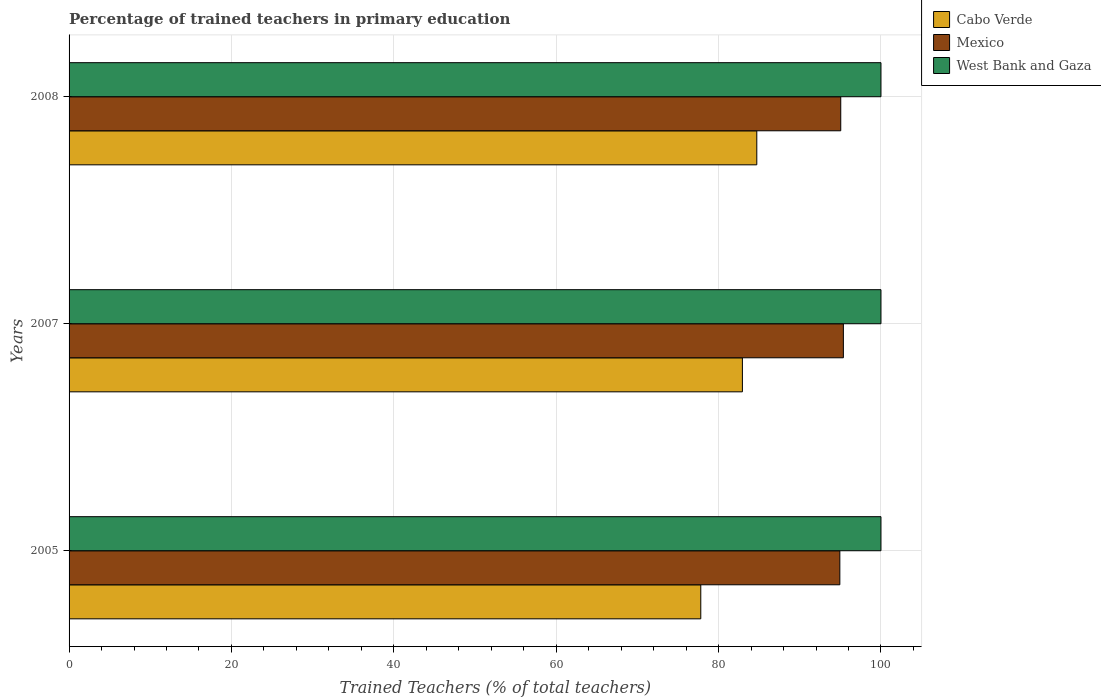How many different coloured bars are there?
Your answer should be compact. 3. How many bars are there on the 3rd tick from the top?
Your answer should be very brief. 3. In how many cases, is the number of bars for a given year not equal to the number of legend labels?
Your answer should be compact. 0. What is the percentage of trained teachers in Mexico in 2007?
Offer a terse response. 95.37. In which year was the percentage of trained teachers in Mexico minimum?
Offer a very short reply. 2005. What is the total percentage of trained teachers in West Bank and Gaza in the graph?
Keep it short and to the point. 300. What is the difference between the percentage of trained teachers in Cabo Verde in 2005 and that in 2008?
Provide a short and direct response. -6.9. What is the difference between the percentage of trained teachers in Cabo Verde in 2005 and the percentage of trained teachers in West Bank and Gaza in 2008?
Keep it short and to the point. -22.19. What is the average percentage of trained teachers in Mexico per year?
Make the answer very short. 95.12. In the year 2007, what is the difference between the percentage of trained teachers in Mexico and percentage of trained teachers in West Bank and Gaza?
Offer a very short reply. -4.63. In how many years, is the percentage of trained teachers in Mexico greater than 56 %?
Make the answer very short. 3. What is the ratio of the percentage of trained teachers in Mexico in 2005 to that in 2008?
Make the answer very short. 1. Is the percentage of trained teachers in Cabo Verde in 2007 less than that in 2008?
Your answer should be very brief. Yes. What is the difference between the highest and the second highest percentage of trained teachers in Cabo Verde?
Keep it short and to the point. 1.77. Is it the case that in every year, the sum of the percentage of trained teachers in Mexico and percentage of trained teachers in West Bank and Gaza is greater than the percentage of trained teachers in Cabo Verde?
Your response must be concise. Yes. How many bars are there?
Offer a terse response. 9. What is the difference between two consecutive major ticks on the X-axis?
Your answer should be compact. 20. Are the values on the major ticks of X-axis written in scientific E-notation?
Provide a short and direct response. No. What is the title of the graph?
Make the answer very short. Percentage of trained teachers in primary education. Does "Honduras" appear as one of the legend labels in the graph?
Your answer should be very brief. No. What is the label or title of the X-axis?
Ensure brevity in your answer.  Trained Teachers (% of total teachers). What is the label or title of the Y-axis?
Make the answer very short. Years. What is the Trained Teachers (% of total teachers) of Cabo Verde in 2005?
Give a very brief answer. 77.81. What is the Trained Teachers (% of total teachers) in Mexico in 2005?
Provide a succinct answer. 94.93. What is the Trained Teachers (% of total teachers) in Cabo Verde in 2007?
Offer a very short reply. 82.93. What is the Trained Teachers (% of total teachers) of Mexico in 2007?
Keep it short and to the point. 95.37. What is the Trained Teachers (% of total teachers) of West Bank and Gaza in 2007?
Your response must be concise. 100. What is the Trained Teachers (% of total teachers) in Cabo Verde in 2008?
Keep it short and to the point. 84.71. What is the Trained Teachers (% of total teachers) of Mexico in 2008?
Give a very brief answer. 95.05. What is the Trained Teachers (% of total teachers) of West Bank and Gaza in 2008?
Make the answer very short. 100. Across all years, what is the maximum Trained Teachers (% of total teachers) of Cabo Verde?
Offer a terse response. 84.71. Across all years, what is the maximum Trained Teachers (% of total teachers) of Mexico?
Ensure brevity in your answer.  95.37. Across all years, what is the maximum Trained Teachers (% of total teachers) in West Bank and Gaza?
Ensure brevity in your answer.  100. Across all years, what is the minimum Trained Teachers (% of total teachers) in Cabo Verde?
Provide a short and direct response. 77.81. Across all years, what is the minimum Trained Teachers (% of total teachers) of Mexico?
Offer a very short reply. 94.93. What is the total Trained Teachers (% of total teachers) of Cabo Verde in the graph?
Give a very brief answer. 245.45. What is the total Trained Teachers (% of total teachers) in Mexico in the graph?
Provide a short and direct response. 285.35. What is the total Trained Teachers (% of total teachers) in West Bank and Gaza in the graph?
Your response must be concise. 300. What is the difference between the Trained Teachers (% of total teachers) of Cabo Verde in 2005 and that in 2007?
Provide a short and direct response. -5.13. What is the difference between the Trained Teachers (% of total teachers) of Mexico in 2005 and that in 2007?
Your answer should be compact. -0.43. What is the difference between the Trained Teachers (% of total teachers) of West Bank and Gaza in 2005 and that in 2007?
Your answer should be compact. 0. What is the difference between the Trained Teachers (% of total teachers) of Cabo Verde in 2005 and that in 2008?
Your answer should be compact. -6.9. What is the difference between the Trained Teachers (% of total teachers) of Mexico in 2005 and that in 2008?
Your response must be concise. -0.11. What is the difference between the Trained Teachers (% of total teachers) in Cabo Verde in 2007 and that in 2008?
Offer a very short reply. -1.77. What is the difference between the Trained Teachers (% of total teachers) in Mexico in 2007 and that in 2008?
Make the answer very short. 0.32. What is the difference between the Trained Teachers (% of total teachers) in Cabo Verde in 2005 and the Trained Teachers (% of total teachers) in Mexico in 2007?
Give a very brief answer. -17.56. What is the difference between the Trained Teachers (% of total teachers) in Cabo Verde in 2005 and the Trained Teachers (% of total teachers) in West Bank and Gaza in 2007?
Make the answer very short. -22.19. What is the difference between the Trained Teachers (% of total teachers) of Mexico in 2005 and the Trained Teachers (% of total teachers) of West Bank and Gaza in 2007?
Provide a succinct answer. -5.07. What is the difference between the Trained Teachers (% of total teachers) in Cabo Verde in 2005 and the Trained Teachers (% of total teachers) in Mexico in 2008?
Provide a succinct answer. -17.24. What is the difference between the Trained Teachers (% of total teachers) of Cabo Verde in 2005 and the Trained Teachers (% of total teachers) of West Bank and Gaza in 2008?
Provide a short and direct response. -22.19. What is the difference between the Trained Teachers (% of total teachers) of Mexico in 2005 and the Trained Teachers (% of total teachers) of West Bank and Gaza in 2008?
Keep it short and to the point. -5.07. What is the difference between the Trained Teachers (% of total teachers) in Cabo Verde in 2007 and the Trained Teachers (% of total teachers) in Mexico in 2008?
Your response must be concise. -12.11. What is the difference between the Trained Teachers (% of total teachers) in Cabo Verde in 2007 and the Trained Teachers (% of total teachers) in West Bank and Gaza in 2008?
Provide a succinct answer. -17.07. What is the difference between the Trained Teachers (% of total teachers) in Mexico in 2007 and the Trained Teachers (% of total teachers) in West Bank and Gaza in 2008?
Your answer should be compact. -4.63. What is the average Trained Teachers (% of total teachers) of Cabo Verde per year?
Ensure brevity in your answer.  81.82. What is the average Trained Teachers (% of total teachers) of Mexico per year?
Keep it short and to the point. 95.12. What is the average Trained Teachers (% of total teachers) in West Bank and Gaza per year?
Keep it short and to the point. 100. In the year 2005, what is the difference between the Trained Teachers (% of total teachers) of Cabo Verde and Trained Teachers (% of total teachers) of Mexico?
Your response must be concise. -17.13. In the year 2005, what is the difference between the Trained Teachers (% of total teachers) in Cabo Verde and Trained Teachers (% of total teachers) in West Bank and Gaza?
Your response must be concise. -22.19. In the year 2005, what is the difference between the Trained Teachers (% of total teachers) of Mexico and Trained Teachers (% of total teachers) of West Bank and Gaza?
Your answer should be compact. -5.07. In the year 2007, what is the difference between the Trained Teachers (% of total teachers) in Cabo Verde and Trained Teachers (% of total teachers) in Mexico?
Your answer should be very brief. -12.43. In the year 2007, what is the difference between the Trained Teachers (% of total teachers) in Cabo Verde and Trained Teachers (% of total teachers) in West Bank and Gaza?
Make the answer very short. -17.07. In the year 2007, what is the difference between the Trained Teachers (% of total teachers) in Mexico and Trained Teachers (% of total teachers) in West Bank and Gaza?
Provide a short and direct response. -4.63. In the year 2008, what is the difference between the Trained Teachers (% of total teachers) of Cabo Verde and Trained Teachers (% of total teachers) of Mexico?
Your answer should be compact. -10.34. In the year 2008, what is the difference between the Trained Teachers (% of total teachers) of Cabo Verde and Trained Teachers (% of total teachers) of West Bank and Gaza?
Provide a short and direct response. -15.29. In the year 2008, what is the difference between the Trained Teachers (% of total teachers) in Mexico and Trained Teachers (% of total teachers) in West Bank and Gaza?
Offer a very short reply. -4.95. What is the ratio of the Trained Teachers (% of total teachers) in Cabo Verde in 2005 to that in 2007?
Your answer should be very brief. 0.94. What is the ratio of the Trained Teachers (% of total teachers) in Mexico in 2005 to that in 2007?
Give a very brief answer. 1. What is the ratio of the Trained Teachers (% of total teachers) of West Bank and Gaza in 2005 to that in 2007?
Keep it short and to the point. 1. What is the ratio of the Trained Teachers (% of total teachers) in Cabo Verde in 2005 to that in 2008?
Give a very brief answer. 0.92. What is the ratio of the Trained Teachers (% of total teachers) in Mexico in 2005 to that in 2008?
Your answer should be very brief. 1. What is the ratio of the Trained Teachers (% of total teachers) of Cabo Verde in 2007 to that in 2008?
Give a very brief answer. 0.98. What is the ratio of the Trained Teachers (% of total teachers) of Mexico in 2007 to that in 2008?
Provide a succinct answer. 1. What is the difference between the highest and the second highest Trained Teachers (% of total teachers) of Cabo Verde?
Offer a terse response. 1.77. What is the difference between the highest and the second highest Trained Teachers (% of total teachers) in Mexico?
Provide a short and direct response. 0.32. What is the difference between the highest and the second highest Trained Teachers (% of total teachers) in West Bank and Gaza?
Offer a terse response. 0. What is the difference between the highest and the lowest Trained Teachers (% of total teachers) in Cabo Verde?
Ensure brevity in your answer.  6.9. What is the difference between the highest and the lowest Trained Teachers (% of total teachers) in Mexico?
Offer a terse response. 0.43. What is the difference between the highest and the lowest Trained Teachers (% of total teachers) of West Bank and Gaza?
Make the answer very short. 0. 